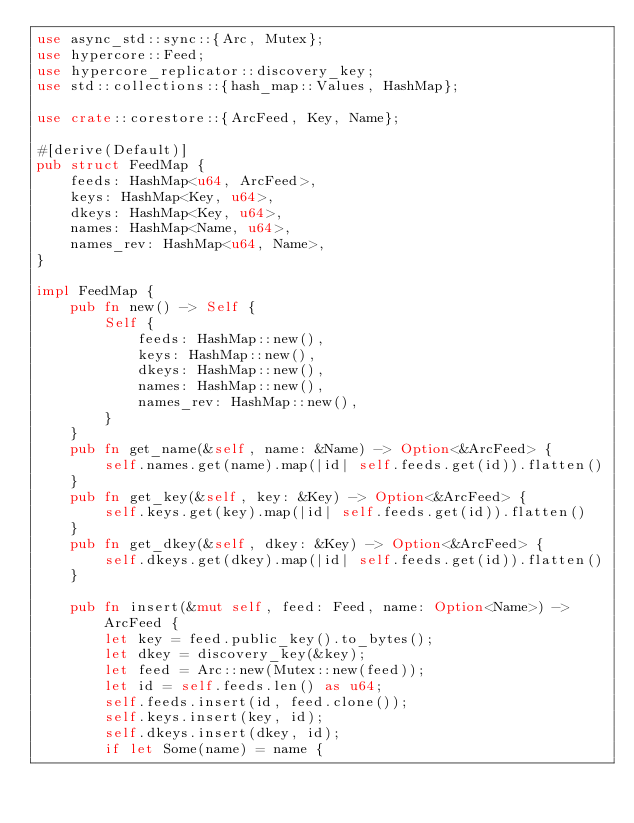<code> <loc_0><loc_0><loc_500><loc_500><_Rust_>use async_std::sync::{Arc, Mutex};
use hypercore::Feed;
use hypercore_replicator::discovery_key;
use std::collections::{hash_map::Values, HashMap};

use crate::corestore::{ArcFeed, Key, Name};

#[derive(Default)]
pub struct FeedMap {
    feeds: HashMap<u64, ArcFeed>,
    keys: HashMap<Key, u64>,
    dkeys: HashMap<Key, u64>,
    names: HashMap<Name, u64>,
    names_rev: HashMap<u64, Name>,
}

impl FeedMap {
    pub fn new() -> Self {
        Self {
            feeds: HashMap::new(),
            keys: HashMap::new(),
            dkeys: HashMap::new(),
            names: HashMap::new(),
            names_rev: HashMap::new(),
        }
    }
    pub fn get_name(&self, name: &Name) -> Option<&ArcFeed> {
        self.names.get(name).map(|id| self.feeds.get(id)).flatten()
    }
    pub fn get_key(&self, key: &Key) -> Option<&ArcFeed> {
        self.keys.get(key).map(|id| self.feeds.get(id)).flatten()
    }
    pub fn get_dkey(&self, dkey: &Key) -> Option<&ArcFeed> {
        self.dkeys.get(dkey).map(|id| self.feeds.get(id)).flatten()
    }

    pub fn insert(&mut self, feed: Feed, name: Option<Name>) -> ArcFeed {
        let key = feed.public_key().to_bytes();
        let dkey = discovery_key(&key);
        let feed = Arc::new(Mutex::new(feed));
        let id = self.feeds.len() as u64;
        self.feeds.insert(id, feed.clone());
        self.keys.insert(key, id);
        self.dkeys.insert(dkey, id);
        if let Some(name) = name {</code> 